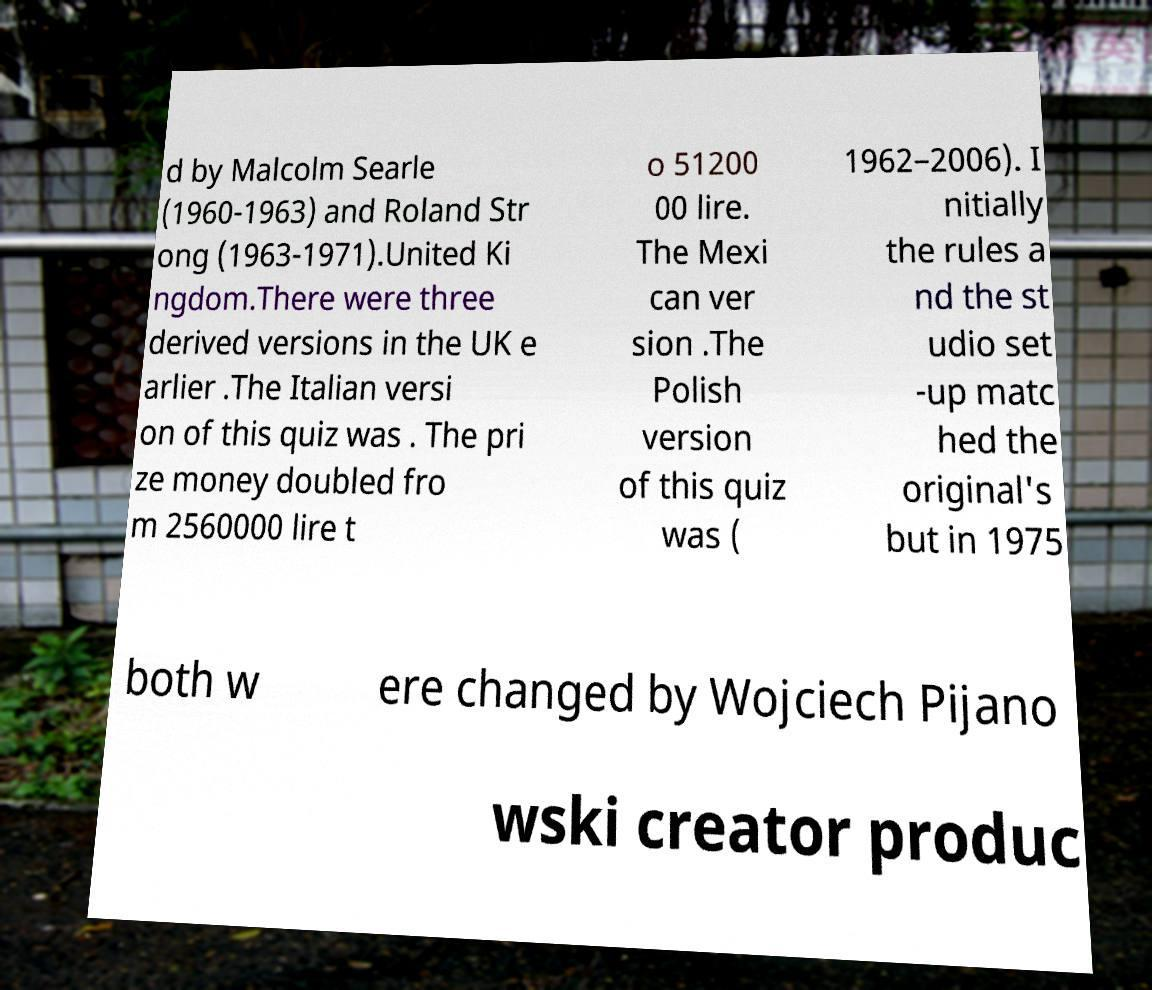For documentation purposes, I need the text within this image transcribed. Could you provide that? d by Malcolm Searle (1960-1963) and Roland Str ong (1963-1971).United Ki ngdom.There were three derived versions in the UK e arlier .The Italian versi on of this quiz was . The pri ze money doubled fro m 2560000 lire t o 51200 00 lire. The Mexi can ver sion .The Polish version of this quiz was ( 1962–2006). I nitially the rules a nd the st udio set -up matc hed the original's but in 1975 both w ere changed by Wojciech Pijano wski creator produc 